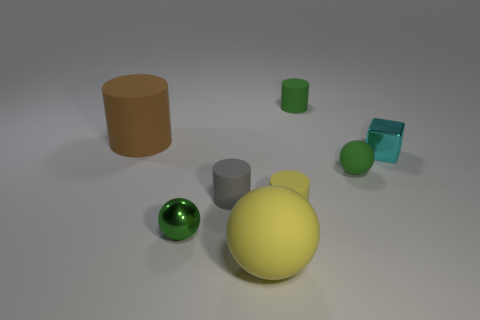What objects are present in the image? The image contains several 3D shapes placed randomly on a surface: a tall brown cylinder, a small green cylinder, a light blue transparent cube, a solid grey cylinder, a green sphere, and a large yellow ellipsoid. 